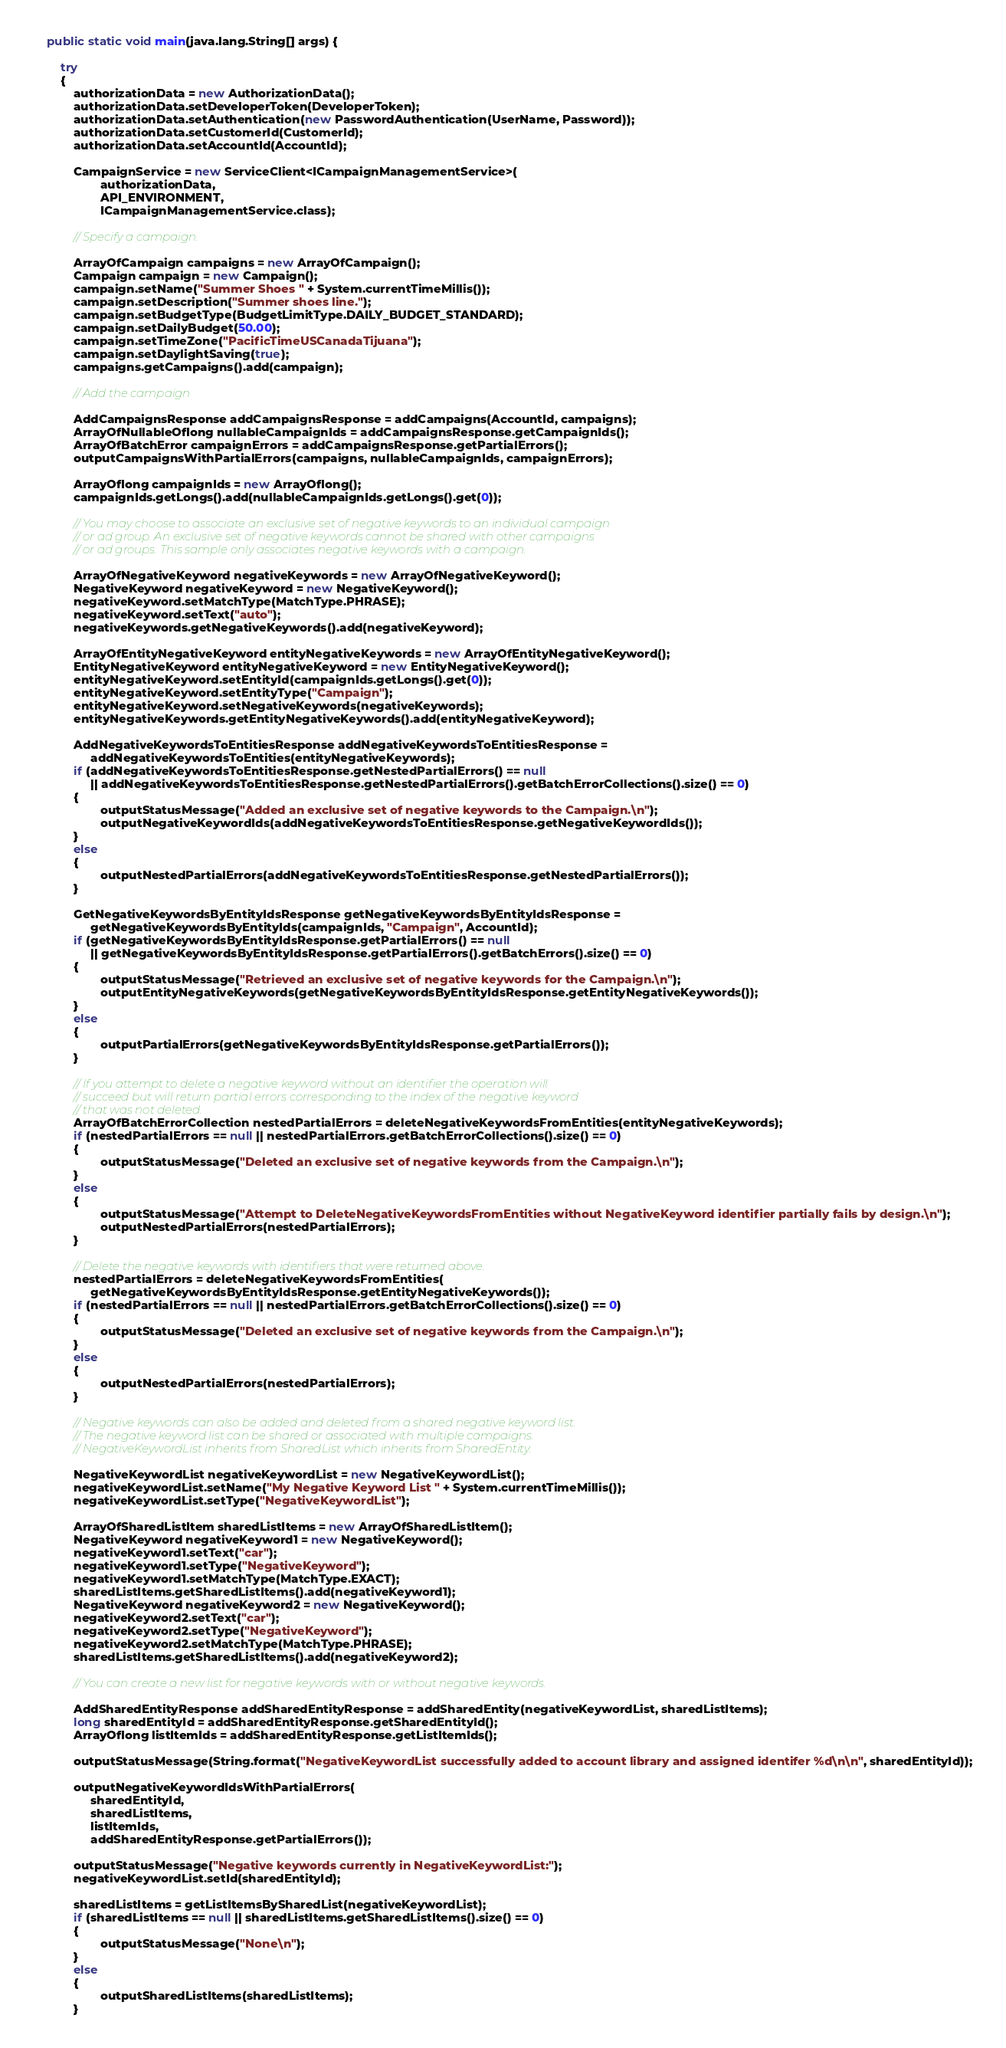<code> <loc_0><loc_0><loc_500><loc_500><_Java_>
    public static void main(java.lang.String[] args) {
	 
        try
        {
            authorizationData = new AuthorizationData();
            authorizationData.setDeveloperToken(DeveloperToken);
            authorizationData.setAuthentication(new PasswordAuthentication(UserName, Password));
            authorizationData.setCustomerId(CustomerId);
            authorizationData.setAccountId(AccountId);

            CampaignService = new ServiceClient<ICampaignManagementService>(
                    authorizationData, 
                    API_ENVIRONMENT,
                    ICampaignManagementService.class);

            // Specify a campaign. 

            ArrayOfCampaign campaigns = new ArrayOfCampaign();
            Campaign campaign = new Campaign();
            campaign.setName("Summer Shoes " + System.currentTimeMillis());
            campaign.setDescription("Summer shoes line.");
            campaign.setBudgetType(BudgetLimitType.DAILY_BUDGET_STANDARD);
            campaign.setDailyBudget(50.00);
            campaign.setTimeZone("PacificTimeUSCanadaTijuana");
            campaign.setDaylightSaving(true);
            campaigns.getCampaigns().add(campaign);
			
            // Add the campaign
			 
            AddCampaignsResponse addCampaignsResponse = addCampaigns(AccountId, campaigns);
            ArrayOfNullableOflong nullableCampaignIds = addCampaignsResponse.getCampaignIds();
            ArrayOfBatchError campaignErrors = addCampaignsResponse.getPartialErrors();
            outputCampaignsWithPartialErrors(campaigns, nullableCampaignIds, campaignErrors);
            
            ArrayOflong campaignIds = new ArrayOflong();
            campaignIds.getLongs().add(nullableCampaignIds.getLongs().get(0));
			
            // You may choose to associate an exclusive set of negative keywords to an individual campaign 
            // or ad group. An exclusive set of negative keywords cannot be shared with other campaigns 
            // or ad groups. This sample only associates negative keywords with a campaign.

            ArrayOfNegativeKeyword negativeKeywords = new ArrayOfNegativeKeyword();
            NegativeKeyword negativeKeyword = new NegativeKeyword();
            negativeKeyword.setMatchType(MatchType.PHRASE);
            negativeKeyword.setText("auto");
            negativeKeywords.getNegativeKeywords().add(negativeKeyword);

            ArrayOfEntityNegativeKeyword entityNegativeKeywords = new ArrayOfEntityNegativeKeyword();
            EntityNegativeKeyword entityNegativeKeyword = new EntityNegativeKeyword();
            entityNegativeKeyword.setEntityId(campaignIds.getLongs().get(0));
            entityNegativeKeyword.setEntityType("Campaign");
            entityNegativeKeyword.setNegativeKeywords(negativeKeywords);
            entityNegativeKeywords.getEntityNegativeKeywords().add(entityNegativeKeyword);

            AddNegativeKeywordsToEntitiesResponse addNegativeKeywordsToEntitiesResponse = 
                 addNegativeKeywordsToEntities(entityNegativeKeywords);
            if (addNegativeKeywordsToEntitiesResponse.getNestedPartialErrors() == null
                 || addNegativeKeywordsToEntitiesResponse.getNestedPartialErrors().getBatchErrorCollections().size() == 0)
            {
                    outputStatusMessage("Added an exclusive set of negative keywords to the Campaign.\n");
                    outputNegativeKeywordIds(addNegativeKeywordsToEntitiesResponse.getNegativeKeywordIds());
            }
            else
            {
                    outputNestedPartialErrors(addNegativeKeywordsToEntitiesResponse.getNestedPartialErrors());
            }

            GetNegativeKeywordsByEntityIdsResponse getNegativeKeywordsByEntityIdsResponse = 
                 getNegativeKeywordsByEntityIds(campaignIds, "Campaign", AccountId);
            if (getNegativeKeywordsByEntityIdsResponse.getPartialErrors() == null
                 || getNegativeKeywordsByEntityIdsResponse.getPartialErrors().getBatchErrors().size() == 0)
            {
                    outputStatusMessage("Retrieved an exclusive set of negative keywords for the Campaign.\n");
                    outputEntityNegativeKeywords(getNegativeKeywordsByEntityIdsResponse.getEntityNegativeKeywords());
            }
            else
            {
                    outputPartialErrors(getNegativeKeywordsByEntityIdsResponse.getPartialErrors());
            }

            // If you attempt to delete a negative keyword without an identifier the operation will
            // succeed but will return partial errors corresponding to the index of the negative keyword
            // that was not deleted. 
            ArrayOfBatchErrorCollection nestedPartialErrors = deleteNegativeKeywordsFromEntities(entityNegativeKeywords);
            if (nestedPartialErrors == null || nestedPartialErrors.getBatchErrorCollections().size() == 0)
            {
                    outputStatusMessage("Deleted an exclusive set of negative keywords from the Campaign.\n");
            }
            else
            {
                    outputStatusMessage("Attempt to DeleteNegativeKeywordsFromEntities without NegativeKeyword identifier partially fails by design.\n");
                    outputNestedPartialErrors(nestedPartialErrors);
            }

            // Delete the negative keywords with identifiers that were returned above.
            nestedPartialErrors = deleteNegativeKeywordsFromEntities(
                 getNegativeKeywordsByEntityIdsResponse.getEntityNegativeKeywords());
            if (nestedPartialErrors == null || nestedPartialErrors.getBatchErrorCollections().size() == 0)
            {
                    outputStatusMessage("Deleted an exclusive set of negative keywords from the Campaign.\n");
            }
            else
            {
                    outputNestedPartialErrors(nestedPartialErrors);
            }

            // Negative keywords can also be added and deleted from a shared negative keyword list. 
            // The negative keyword list can be shared or associated with multiple campaigns.
            // NegativeKeywordList inherits from SharedList which inherits from SharedEntity.

            NegativeKeywordList negativeKeywordList = new NegativeKeywordList();
            negativeKeywordList.setName("My Negative Keyword List " + System.currentTimeMillis());
            negativeKeywordList.setType("NegativeKeywordList");

            ArrayOfSharedListItem sharedListItems = new ArrayOfSharedListItem();
            NegativeKeyword negativeKeyword1 = new NegativeKeyword();
            negativeKeyword1.setText("car");
            negativeKeyword1.setType("NegativeKeyword");
            negativeKeyword1.setMatchType(MatchType.EXACT);
            sharedListItems.getSharedListItems().add(negativeKeyword1);
            NegativeKeyword negativeKeyword2 = new NegativeKeyword();
            negativeKeyword2.setText("car");
            negativeKeyword2.setType("NegativeKeyword");
            negativeKeyword2.setMatchType(MatchType.PHRASE);
            sharedListItems.getSharedListItems().add(negativeKeyword2);

            // You can create a new list for negative keywords with or without negative keywords.

            AddSharedEntityResponse addSharedEntityResponse = addSharedEntity(negativeKeywordList, sharedListItems);
            long sharedEntityId = addSharedEntityResponse.getSharedEntityId();
            ArrayOflong listItemIds = addSharedEntityResponse.getListItemIds();

            outputStatusMessage(String.format("NegativeKeywordList successfully added to account library and assigned identifer %d\n\n", sharedEntityId));

            outputNegativeKeywordIdsWithPartialErrors(
                 sharedEntityId,
                 sharedListItems, 
                 listItemIds, 
                 addSharedEntityResponse.getPartialErrors());

            outputStatusMessage("Negative keywords currently in NegativeKeywordList:");
            negativeKeywordList.setId(sharedEntityId);

            sharedListItems = getListItemsBySharedList(negativeKeywordList);
            if (sharedListItems == null || sharedListItems.getSharedListItems().size() == 0)
            {
                    outputStatusMessage("None\n");
            }
            else
            {
                    outputSharedListItems(sharedListItems);
            }             
</code> 